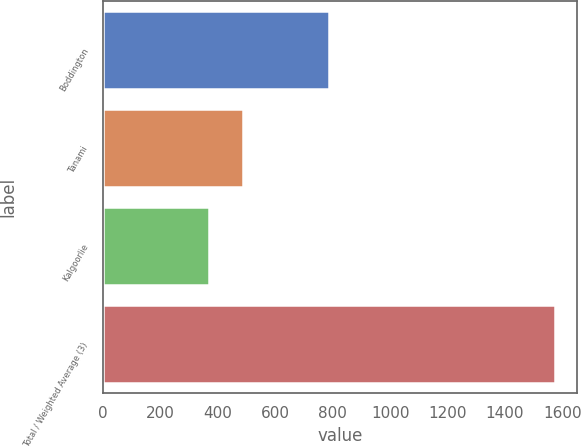Convert chart. <chart><loc_0><loc_0><loc_500><loc_500><bar_chart><fcel>Boddington<fcel>Tanami<fcel>Kalgoorlie<fcel>Total / Weighted Average (3)<nl><fcel>787<fcel>487.6<fcel>367<fcel>1573<nl></chart> 